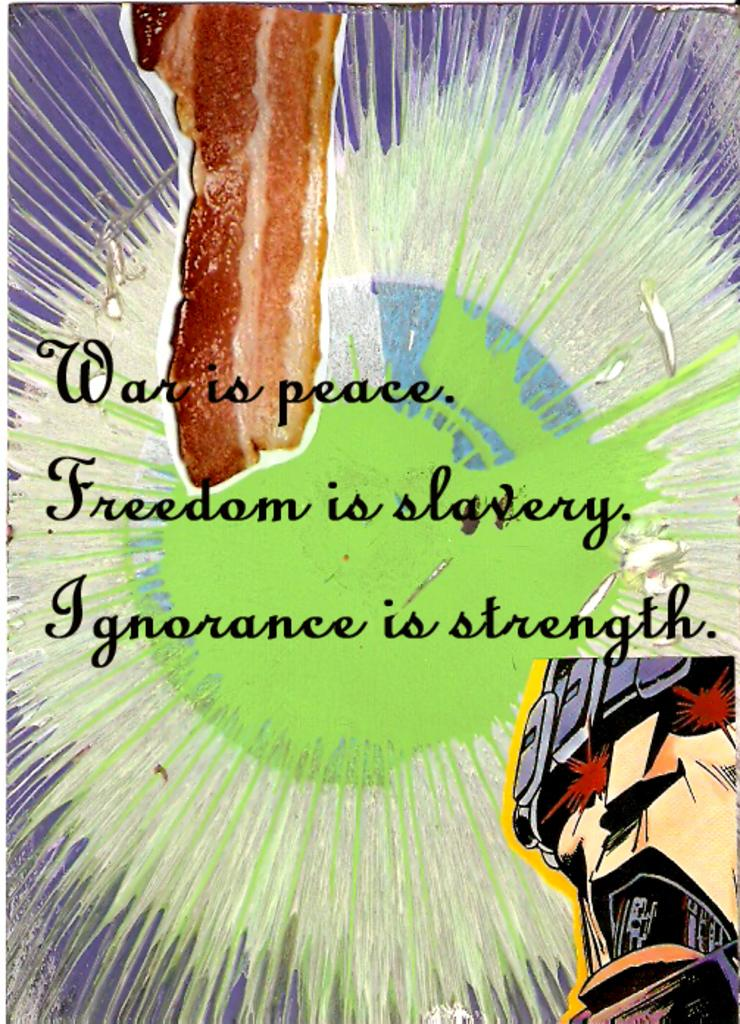<image>
Relay a brief, clear account of the picture shown. The quote that stands out here is War is Peace 